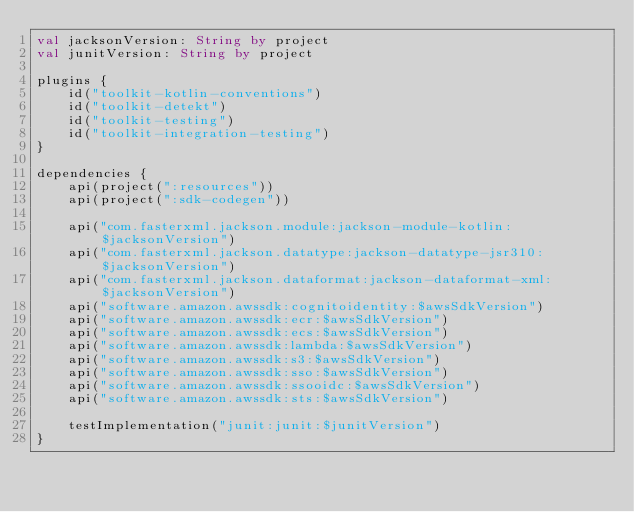<code> <loc_0><loc_0><loc_500><loc_500><_Kotlin_>val jacksonVersion: String by project
val junitVersion: String by project

plugins {
    id("toolkit-kotlin-conventions")
    id("toolkit-detekt")
    id("toolkit-testing")
    id("toolkit-integration-testing")
}

dependencies {
    api(project(":resources"))
    api(project(":sdk-codegen"))

    api("com.fasterxml.jackson.module:jackson-module-kotlin:$jacksonVersion")
    api("com.fasterxml.jackson.datatype:jackson-datatype-jsr310:$jacksonVersion")
    api("com.fasterxml.jackson.dataformat:jackson-dataformat-xml:$jacksonVersion")
    api("software.amazon.awssdk:cognitoidentity:$awsSdkVersion")
    api("software.amazon.awssdk:ecr:$awsSdkVersion")
    api("software.amazon.awssdk:ecs:$awsSdkVersion")
    api("software.amazon.awssdk:lambda:$awsSdkVersion")
    api("software.amazon.awssdk:s3:$awsSdkVersion")
    api("software.amazon.awssdk:sso:$awsSdkVersion")
    api("software.amazon.awssdk:ssooidc:$awsSdkVersion")
    api("software.amazon.awssdk:sts:$awsSdkVersion")

    testImplementation("junit:junit:$junitVersion")
}
</code> 